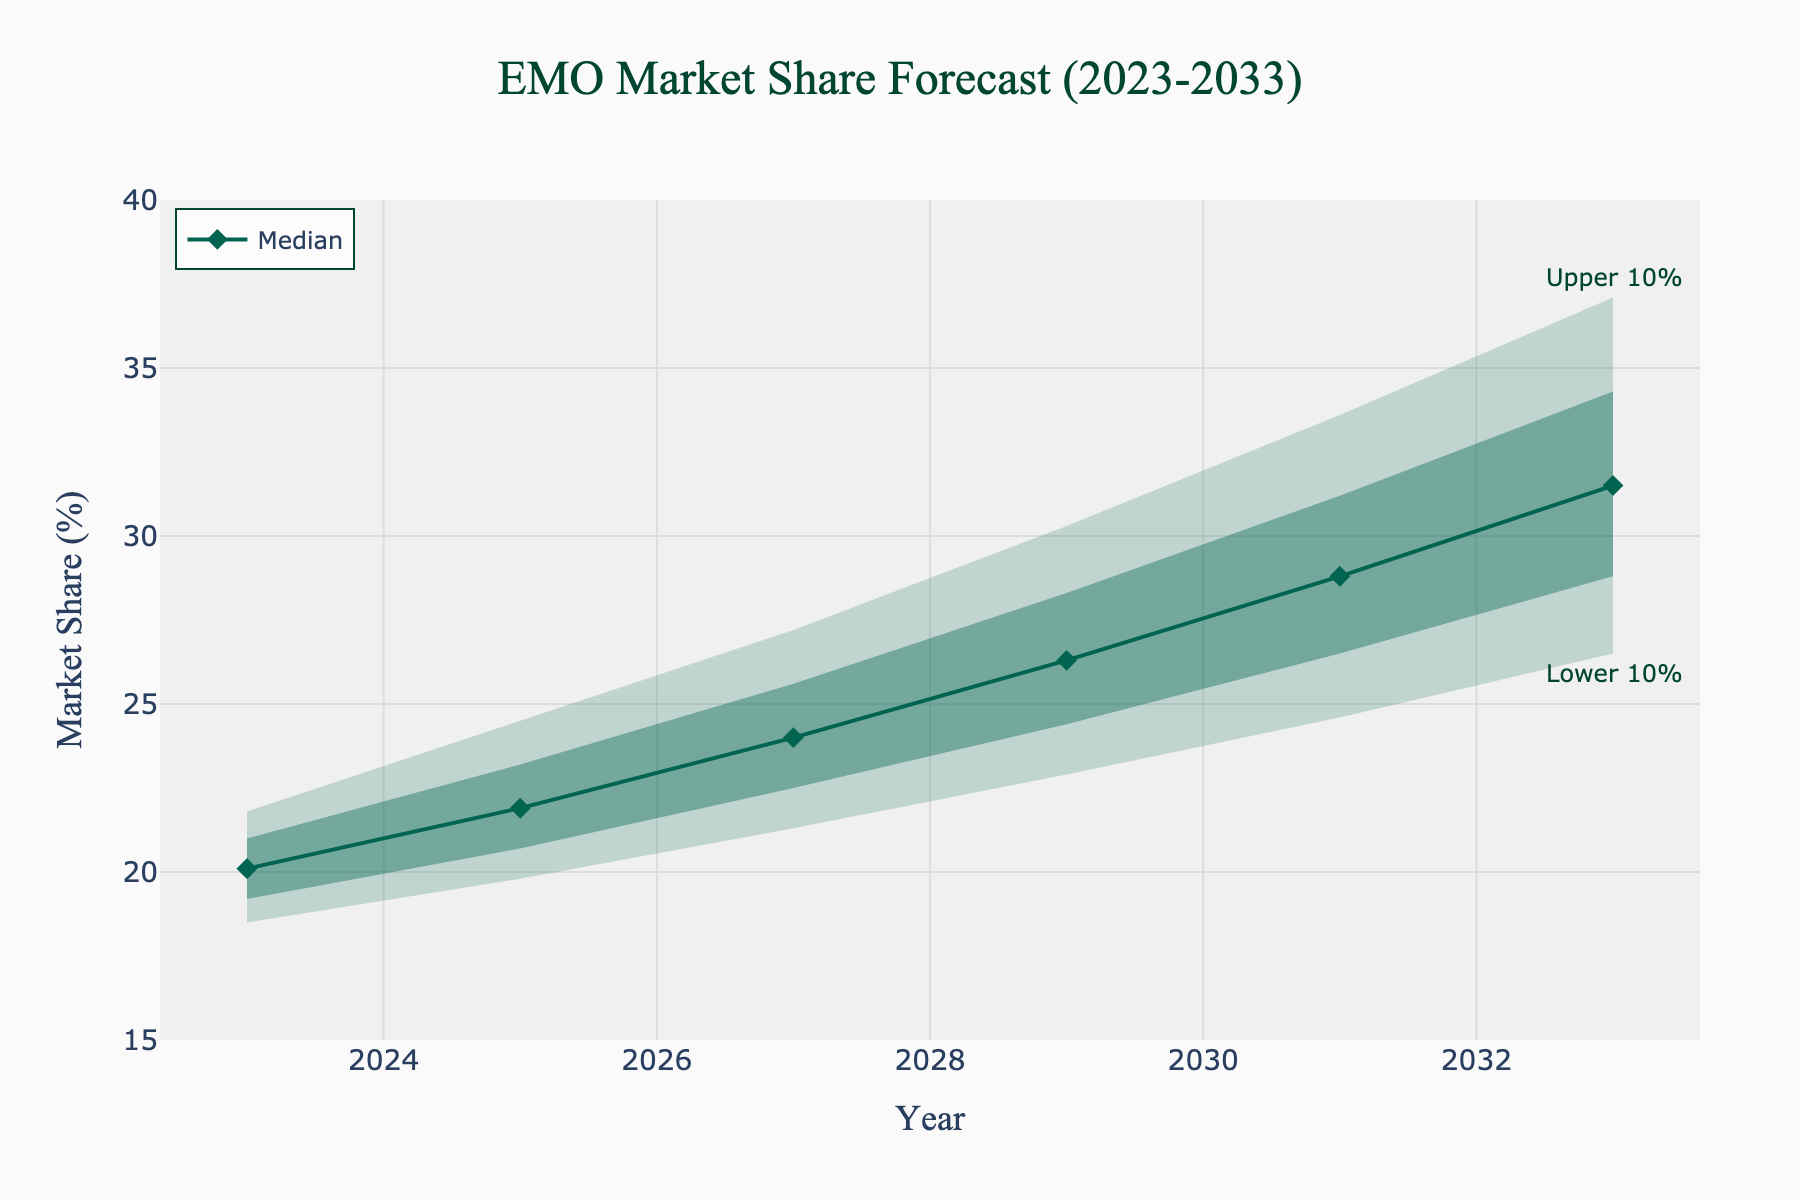What is the title of the chart? The title is prominently displayed at the top center of the chart. It reads "EMO Market Share Forecast (2023-2033)".
Answer: EMO Market Share Forecast (2023-2033) How does the median market share trend from 2023 to 2033? By looking at the median line, which is denoted by the points connected with a line in the chart, we can see that it increases steadily from 20.1% in 2023 to 31.5% in 2033.
Answer: Increases steadily from 20.1% to 31.5% What is the range of the market share forecast for the year 2027? For 2027, the lower 10% is 21.3%, and the upper 10% is 27.2%. The range is calculated as 27.2% - 21.3%.
Answer: 5.9% In which year does the upper 10% market share reach or exceed 30%? By examining the upper 10% line in the chart, it can be seen that the value reaches 30.3% in the year 2029 and exceeds it in later years.
Answer: 2029 How much is the upper 25% forecasted market share in 2031 higher than the median market share in 2023? The upper 25% forecasted market share in 2031 is 31.2%, and the median market share in 2023 is 20.1%. The difference is calculated as 31.2% - 20.1%.
Answer: 11.1% What's the difference between the lower 10% and lower 25% market share forecast for 2033? For 2033, the lower 10% is 26.5%, and the lower 25% is 28.8%. The difference is calculated as 28.8% - 26.5%.
Answer: 2.3% How does the width of the fan (difference between upper 10% and lower 10%) change from 2023 to 2031? In 2023, the width is (21.8% - 18.5%) = 3.3%. In 2031, the width is (33.6% - 24.6%) = 9.0%. Comparing these values shows that the width increases over time.
Answer: Increases from 3.3% to 9.0% What is the median market share forecast for the year 2029? The median market share forecast for each year is indicated by the line with markers. For 2029, the median value is shown as 26.3%.
Answer: 26.3% In what years does the lower 25% exceed 20%? The lower 25% line exceeds 20% starting from the year 2025 onwards (specifically, it's 20.7% in 2025).
Answer: 2025 onwards By how much does the median market share increase from 2023 to 2029? The median market share in 2023 is 20.1%, and in 2029 it is 26.3%. The increase is calculated as 26.3% - 20.1%.
Answer: 6.2% 